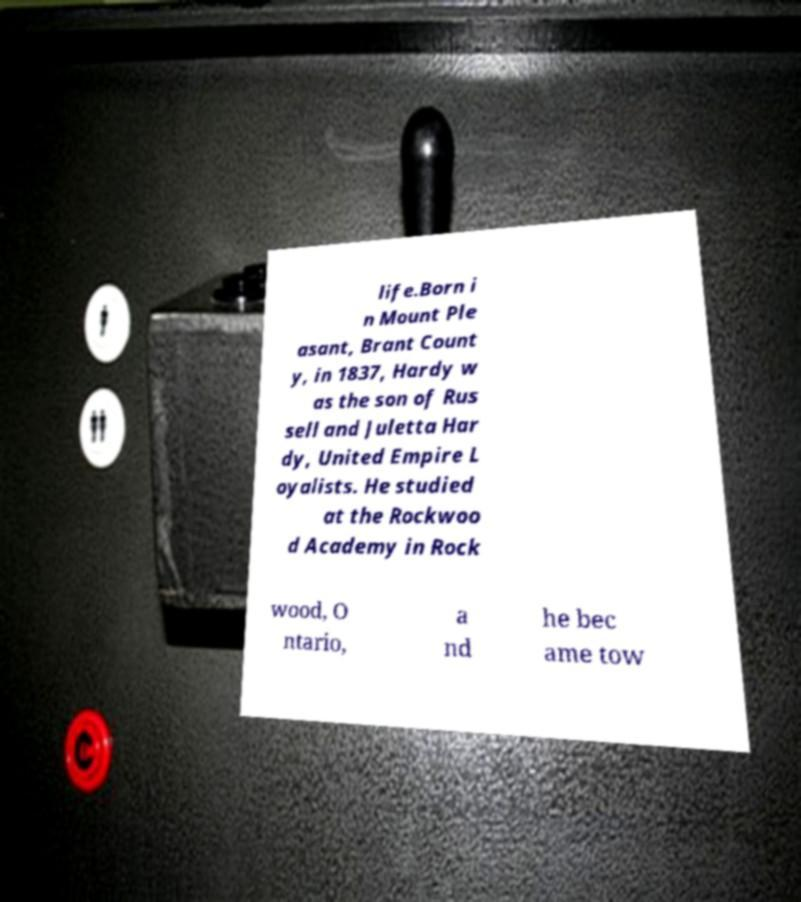Please read and relay the text visible in this image. What does it say? life.Born i n Mount Ple asant, Brant Count y, in 1837, Hardy w as the son of Rus sell and Juletta Har dy, United Empire L oyalists. He studied at the Rockwoo d Academy in Rock wood, O ntario, a nd he bec ame tow 